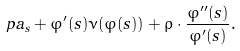Convert formula to latex. <formula><loc_0><loc_0><loc_500><loc_500>\ p a _ { s } + \varphi ^ { \prime } ( s ) \nu ( \varphi ( s ) ) + \rho \cdot \frac { \varphi ^ { \prime \prime } ( s ) } { \varphi ^ { \prime } ( s ) } .</formula> 